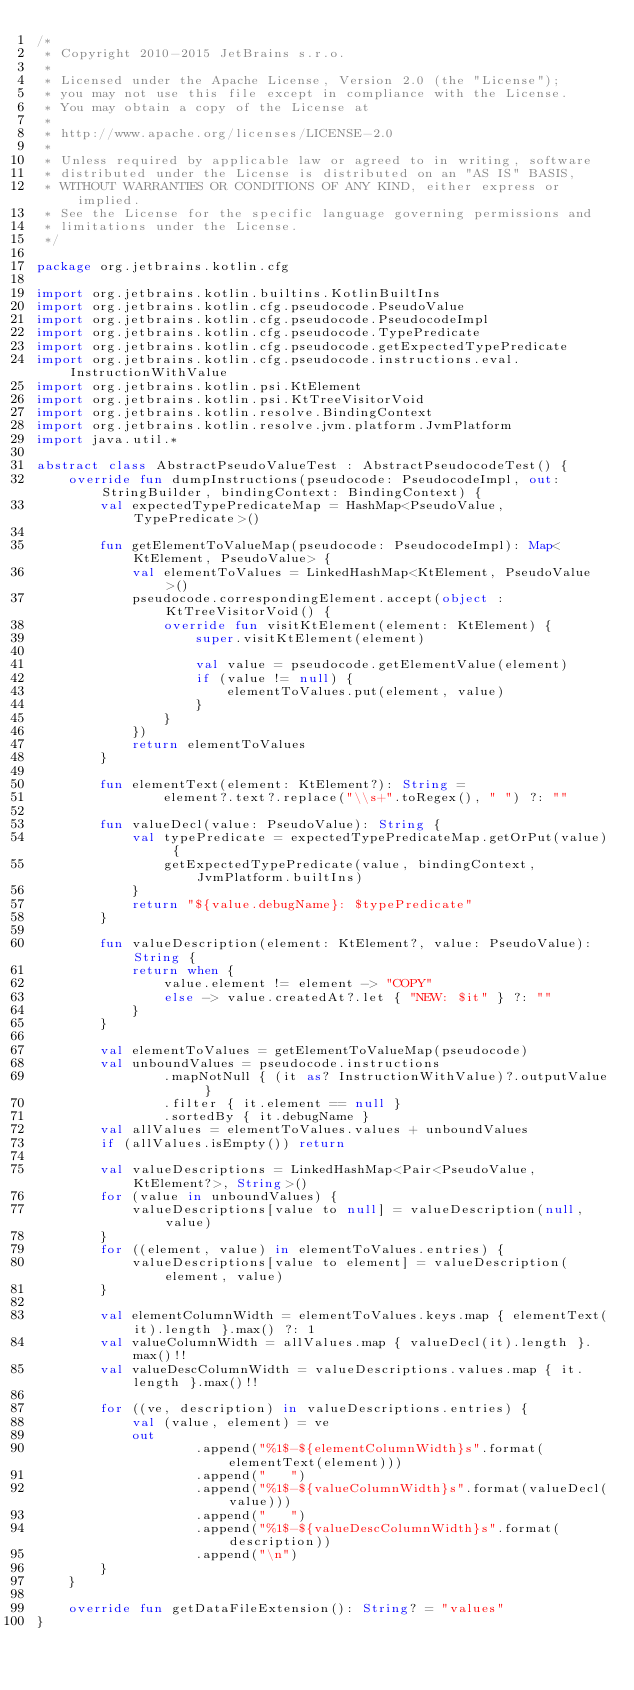<code> <loc_0><loc_0><loc_500><loc_500><_Kotlin_>/*
 * Copyright 2010-2015 JetBrains s.r.o.
 *
 * Licensed under the Apache License, Version 2.0 (the "License");
 * you may not use this file except in compliance with the License.
 * You may obtain a copy of the License at
 *
 * http://www.apache.org/licenses/LICENSE-2.0
 *
 * Unless required by applicable law or agreed to in writing, software
 * distributed under the License is distributed on an "AS IS" BASIS,
 * WITHOUT WARRANTIES OR CONDITIONS OF ANY KIND, either express or implied.
 * See the License for the specific language governing permissions and
 * limitations under the License.
 */

package org.jetbrains.kotlin.cfg

import org.jetbrains.kotlin.builtins.KotlinBuiltIns
import org.jetbrains.kotlin.cfg.pseudocode.PseudoValue
import org.jetbrains.kotlin.cfg.pseudocode.PseudocodeImpl
import org.jetbrains.kotlin.cfg.pseudocode.TypePredicate
import org.jetbrains.kotlin.cfg.pseudocode.getExpectedTypePredicate
import org.jetbrains.kotlin.cfg.pseudocode.instructions.eval.InstructionWithValue
import org.jetbrains.kotlin.psi.KtElement
import org.jetbrains.kotlin.psi.KtTreeVisitorVoid
import org.jetbrains.kotlin.resolve.BindingContext
import org.jetbrains.kotlin.resolve.jvm.platform.JvmPlatform
import java.util.*

abstract class AbstractPseudoValueTest : AbstractPseudocodeTest() {
    override fun dumpInstructions(pseudocode: PseudocodeImpl, out: StringBuilder, bindingContext: BindingContext) {
        val expectedTypePredicateMap = HashMap<PseudoValue, TypePredicate>()

        fun getElementToValueMap(pseudocode: PseudocodeImpl): Map<KtElement, PseudoValue> {
            val elementToValues = LinkedHashMap<KtElement, PseudoValue>()
            pseudocode.correspondingElement.accept(object : KtTreeVisitorVoid() {
                override fun visitKtElement(element: KtElement) {
                    super.visitKtElement(element)

                    val value = pseudocode.getElementValue(element)
                    if (value != null) {
                        elementToValues.put(element, value)
                    }
                }
            })
            return elementToValues
        }

        fun elementText(element: KtElement?): String =
                element?.text?.replace("\\s+".toRegex(), " ") ?: ""

        fun valueDecl(value: PseudoValue): String {
            val typePredicate = expectedTypePredicateMap.getOrPut(value) {
                getExpectedTypePredicate(value, bindingContext, JvmPlatform.builtIns)
            }
            return "${value.debugName}: $typePredicate"
        }

        fun valueDescription(element: KtElement?, value: PseudoValue): String {
            return when {
                value.element != element -> "COPY"
                else -> value.createdAt?.let { "NEW: $it" } ?: ""
            }
        }

        val elementToValues = getElementToValueMap(pseudocode)
        val unboundValues = pseudocode.instructions
                .mapNotNull { (it as? InstructionWithValue)?.outputValue }
                .filter { it.element == null }
                .sortedBy { it.debugName }
        val allValues = elementToValues.values + unboundValues
        if (allValues.isEmpty()) return

        val valueDescriptions = LinkedHashMap<Pair<PseudoValue, KtElement?>, String>()
        for (value in unboundValues) {
            valueDescriptions[value to null] = valueDescription(null, value)
        }
        for ((element, value) in elementToValues.entries) {
            valueDescriptions[value to element] = valueDescription(element, value)
        }

        val elementColumnWidth = elementToValues.keys.map { elementText(it).length }.max() ?: 1
        val valueColumnWidth = allValues.map { valueDecl(it).length }.max()!!
        val valueDescColumnWidth = valueDescriptions.values.map { it.length }.max()!!

        for ((ve, description) in valueDescriptions.entries) {
            val (value, element) = ve
            out
                    .append("%1$-${elementColumnWidth}s".format(elementText(element)))
                    .append("   ")
                    .append("%1$-${valueColumnWidth}s".format(valueDecl(value)))
                    .append("   ")
                    .append("%1$-${valueDescColumnWidth}s".format(description))
                    .append("\n")
        }
    }

    override fun getDataFileExtension(): String? = "values"
}
</code> 